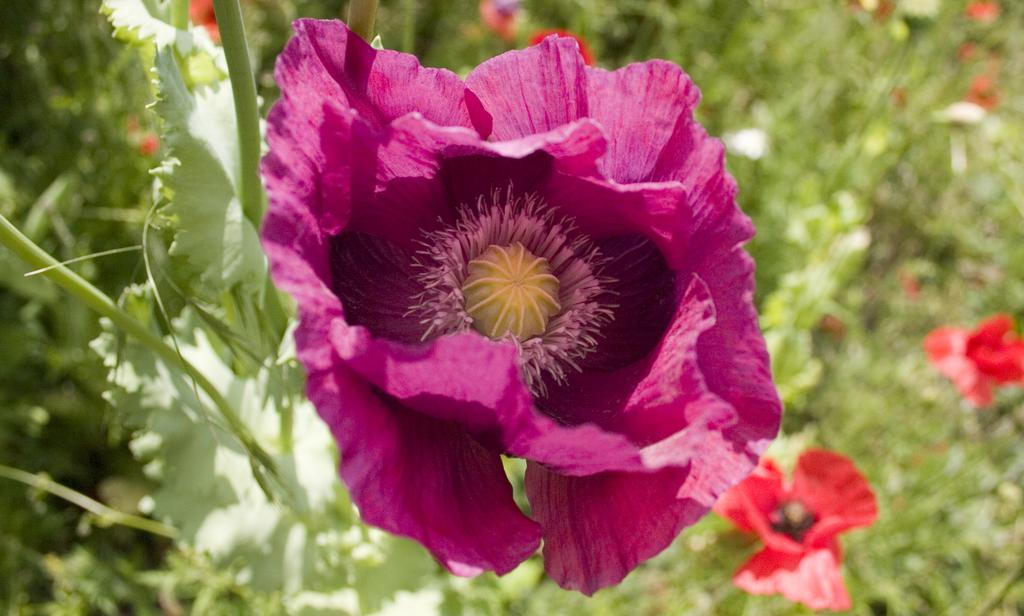What type of plants are visible in the image? There are plants with flowers in the image. Can you describe the background of the image? The background of the image is blurry. How many jellyfish can be seen swimming in the image? There are no jellyfish present in the image. What type of jewel is featured in the image? There is no jewel present in the image. 